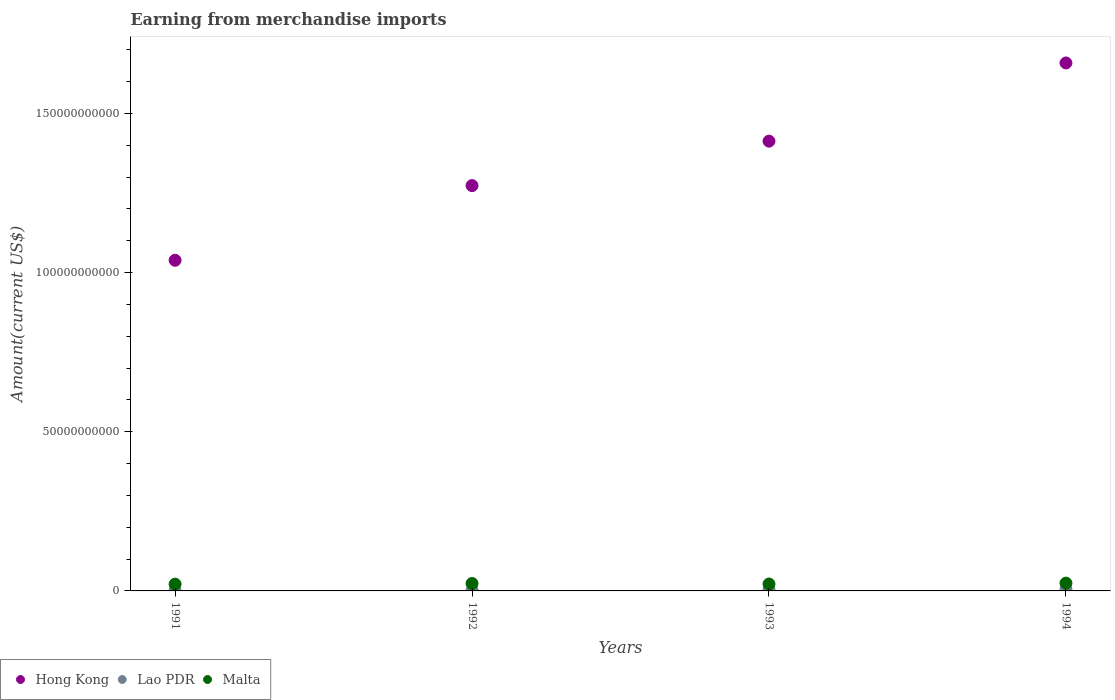Is the number of dotlines equal to the number of legend labels?
Offer a terse response. Yes. What is the amount earned from merchandise imports in Malta in 1992?
Give a very brief answer. 2.33e+09. Across all years, what is the maximum amount earned from merchandise imports in Hong Kong?
Give a very brief answer. 1.66e+11. Across all years, what is the minimum amount earned from merchandise imports in Hong Kong?
Offer a very short reply. 1.04e+11. In which year was the amount earned from merchandise imports in Lao PDR maximum?
Your response must be concise. 1994. In which year was the amount earned from merchandise imports in Hong Kong minimum?
Offer a very short reply. 1991. What is the total amount earned from merchandise imports in Lao PDR in the graph?
Your answer should be compact. 1.44e+09. What is the difference between the amount earned from merchandise imports in Hong Kong in 1993 and that in 1994?
Offer a terse response. -2.46e+1. What is the difference between the amount earned from merchandise imports in Hong Kong in 1991 and the amount earned from merchandise imports in Malta in 1994?
Give a very brief answer. 1.01e+11. What is the average amount earned from merchandise imports in Malta per year?
Offer a very short reply. 2.27e+09. In the year 1993, what is the difference between the amount earned from merchandise imports in Malta and amount earned from merchandise imports in Hong Kong?
Offer a terse response. -1.39e+11. In how many years, is the amount earned from merchandise imports in Lao PDR greater than 140000000000 US$?
Give a very brief answer. 0. What is the ratio of the amount earned from merchandise imports in Malta in 1992 to that in 1993?
Provide a short and direct response. 1.07. Is the difference between the amount earned from merchandise imports in Malta in 1993 and 1994 greater than the difference between the amount earned from merchandise imports in Hong Kong in 1993 and 1994?
Offer a very short reply. Yes. What is the difference between the highest and the second highest amount earned from merchandise imports in Hong Kong?
Provide a short and direct response. 2.46e+1. What is the difference between the highest and the lowest amount earned from merchandise imports in Hong Kong?
Your answer should be compact. 6.20e+1. In how many years, is the amount earned from merchandise imports in Malta greater than the average amount earned from merchandise imports in Malta taken over all years?
Offer a terse response. 2. Is the amount earned from merchandise imports in Hong Kong strictly greater than the amount earned from merchandise imports in Malta over the years?
Provide a short and direct response. Yes. Is the amount earned from merchandise imports in Lao PDR strictly less than the amount earned from merchandise imports in Hong Kong over the years?
Provide a succinct answer. Yes. How many years are there in the graph?
Offer a terse response. 4. What is the difference between two consecutive major ticks on the Y-axis?
Provide a succinct answer. 5.00e+1. Does the graph contain any zero values?
Offer a very short reply. No. Does the graph contain grids?
Provide a succinct answer. No. Where does the legend appear in the graph?
Your answer should be compact. Bottom left. What is the title of the graph?
Provide a succinct answer. Earning from merchandise imports. What is the label or title of the X-axis?
Give a very brief answer. Years. What is the label or title of the Y-axis?
Offer a very short reply. Amount(current US$). What is the Amount(current US$) of Hong Kong in 1991?
Your answer should be very brief. 1.04e+11. What is the Amount(current US$) in Lao PDR in 1991?
Give a very brief answer. 1.70e+08. What is the Amount(current US$) of Malta in 1991?
Your response must be concise. 2.13e+09. What is the Amount(current US$) in Hong Kong in 1992?
Your response must be concise. 1.27e+11. What is the Amount(current US$) of Lao PDR in 1992?
Give a very brief answer. 2.70e+08. What is the Amount(current US$) of Malta in 1992?
Give a very brief answer. 2.33e+09. What is the Amount(current US$) of Hong Kong in 1993?
Your answer should be compact. 1.41e+11. What is the Amount(current US$) in Lao PDR in 1993?
Ensure brevity in your answer.  4.32e+08. What is the Amount(current US$) of Malta in 1993?
Ensure brevity in your answer.  2.17e+09. What is the Amount(current US$) of Hong Kong in 1994?
Your response must be concise. 1.66e+11. What is the Amount(current US$) in Lao PDR in 1994?
Make the answer very short. 5.64e+08. What is the Amount(current US$) of Malta in 1994?
Your answer should be compact. 2.45e+09. Across all years, what is the maximum Amount(current US$) in Hong Kong?
Keep it short and to the point. 1.66e+11. Across all years, what is the maximum Amount(current US$) of Lao PDR?
Keep it short and to the point. 5.64e+08. Across all years, what is the maximum Amount(current US$) in Malta?
Provide a short and direct response. 2.45e+09. Across all years, what is the minimum Amount(current US$) of Hong Kong?
Offer a terse response. 1.04e+11. Across all years, what is the minimum Amount(current US$) of Lao PDR?
Provide a succinct answer. 1.70e+08. Across all years, what is the minimum Amount(current US$) of Malta?
Your answer should be compact. 2.13e+09. What is the total Amount(current US$) in Hong Kong in the graph?
Provide a succinct answer. 5.38e+11. What is the total Amount(current US$) of Lao PDR in the graph?
Ensure brevity in your answer.  1.44e+09. What is the total Amount(current US$) of Malta in the graph?
Your answer should be compact. 9.08e+09. What is the difference between the Amount(current US$) of Hong Kong in 1991 and that in 1992?
Your answer should be compact. -2.35e+1. What is the difference between the Amount(current US$) of Lao PDR in 1991 and that in 1992?
Offer a very short reply. -1.00e+08. What is the difference between the Amount(current US$) in Malta in 1991 and that in 1992?
Your answer should be very brief. -2.01e+08. What is the difference between the Amount(current US$) of Hong Kong in 1991 and that in 1993?
Make the answer very short. -3.74e+1. What is the difference between the Amount(current US$) of Lao PDR in 1991 and that in 1993?
Keep it short and to the point. -2.62e+08. What is the difference between the Amount(current US$) of Malta in 1991 and that in 1993?
Offer a very short reply. -4.40e+07. What is the difference between the Amount(current US$) in Hong Kong in 1991 and that in 1994?
Provide a short and direct response. -6.20e+1. What is the difference between the Amount(current US$) of Lao PDR in 1991 and that in 1994?
Offer a terse response. -3.94e+08. What is the difference between the Amount(current US$) of Malta in 1991 and that in 1994?
Give a very brief answer. -3.17e+08. What is the difference between the Amount(current US$) of Hong Kong in 1992 and that in 1993?
Your answer should be very brief. -1.40e+1. What is the difference between the Amount(current US$) of Lao PDR in 1992 and that in 1993?
Your answer should be compact. -1.62e+08. What is the difference between the Amount(current US$) of Malta in 1992 and that in 1993?
Your answer should be compact. 1.57e+08. What is the difference between the Amount(current US$) of Hong Kong in 1992 and that in 1994?
Your response must be concise. -3.85e+1. What is the difference between the Amount(current US$) in Lao PDR in 1992 and that in 1994?
Offer a terse response. -2.94e+08. What is the difference between the Amount(current US$) in Malta in 1992 and that in 1994?
Give a very brief answer. -1.16e+08. What is the difference between the Amount(current US$) of Hong Kong in 1993 and that in 1994?
Provide a short and direct response. -2.46e+1. What is the difference between the Amount(current US$) of Lao PDR in 1993 and that in 1994?
Offer a terse response. -1.32e+08. What is the difference between the Amount(current US$) of Malta in 1993 and that in 1994?
Ensure brevity in your answer.  -2.73e+08. What is the difference between the Amount(current US$) in Hong Kong in 1991 and the Amount(current US$) in Lao PDR in 1992?
Make the answer very short. 1.04e+11. What is the difference between the Amount(current US$) of Hong Kong in 1991 and the Amount(current US$) of Malta in 1992?
Ensure brevity in your answer.  1.02e+11. What is the difference between the Amount(current US$) of Lao PDR in 1991 and the Amount(current US$) of Malta in 1992?
Ensure brevity in your answer.  -2.16e+09. What is the difference between the Amount(current US$) of Hong Kong in 1991 and the Amount(current US$) of Lao PDR in 1993?
Give a very brief answer. 1.03e+11. What is the difference between the Amount(current US$) of Hong Kong in 1991 and the Amount(current US$) of Malta in 1993?
Provide a short and direct response. 1.02e+11. What is the difference between the Amount(current US$) in Lao PDR in 1991 and the Amount(current US$) in Malta in 1993?
Keep it short and to the point. -2.00e+09. What is the difference between the Amount(current US$) in Hong Kong in 1991 and the Amount(current US$) in Lao PDR in 1994?
Provide a succinct answer. 1.03e+11. What is the difference between the Amount(current US$) of Hong Kong in 1991 and the Amount(current US$) of Malta in 1994?
Provide a succinct answer. 1.01e+11. What is the difference between the Amount(current US$) in Lao PDR in 1991 and the Amount(current US$) in Malta in 1994?
Offer a terse response. -2.28e+09. What is the difference between the Amount(current US$) of Hong Kong in 1992 and the Amount(current US$) of Lao PDR in 1993?
Your answer should be compact. 1.27e+11. What is the difference between the Amount(current US$) of Hong Kong in 1992 and the Amount(current US$) of Malta in 1993?
Offer a terse response. 1.25e+11. What is the difference between the Amount(current US$) of Lao PDR in 1992 and the Amount(current US$) of Malta in 1993?
Offer a terse response. -1.90e+09. What is the difference between the Amount(current US$) in Hong Kong in 1992 and the Amount(current US$) in Lao PDR in 1994?
Your answer should be compact. 1.27e+11. What is the difference between the Amount(current US$) in Hong Kong in 1992 and the Amount(current US$) in Malta in 1994?
Provide a succinct answer. 1.25e+11. What is the difference between the Amount(current US$) of Lao PDR in 1992 and the Amount(current US$) of Malta in 1994?
Offer a very short reply. -2.18e+09. What is the difference between the Amount(current US$) in Hong Kong in 1993 and the Amount(current US$) in Lao PDR in 1994?
Your answer should be very brief. 1.41e+11. What is the difference between the Amount(current US$) in Hong Kong in 1993 and the Amount(current US$) in Malta in 1994?
Provide a short and direct response. 1.39e+11. What is the difference between the Amount(current US$) in Lao PDR in 1993 and the Amount(current US$) in Malta in 1994?
Offer a terse response. -2.02e+09. What is the average Amount(current US$) of Hong Kong per year?
Keep it short and to the point. 1.35e+11. What is the average Amount(current US$) of Lao PDR per year?
Make the answer very short. 3.59e+08. What is the average Amount(current US$) in Malta per year?
Your response must be concise. 2.27e+09. In the year 1991, what is the difference between the Amount(current US$) of Hong Kong and Amount(current US$) of Lao PDR?
Ensure brevity in your answer.  1.04e+11. In the year 1991, what is the difference between the Amount(current US$) in Hong Kong and Amount(current US$) in Malta?
Your answer should be compact. 1.02e+11. In the year 1991, what is the difference between the Amount(current US$) of Lao PDR and Amount(current US$) of Malta?
Your response must be concise. -1.96e+09. In the year 1992, what is the difference between the Amount(current US$) in Hong Kong and Amount(current US$) in Lao PDR?
Offer a very short reply. 1.27e+11. In the year 1992, what is the difference between the Amount(current US$) in Hong Kong and Amount(current US$) in Malta?
Your response must be concise. 1.25e+11. In the year 1992, what is the difference between the Amount(current US$) in Lao PDR and Amount(current US$) in Malta?
Offer a very short reply. -2.06e+09. In the year 1993, what is the difference between the Amount(current US$) of Hong Kong and Amount(current US$) of Lao PDR?
Give a very brief answer. 1.41e+11. In the year 1993, what is the difference between the Amount(current US$) of Hong Kong and Amount(current US$) of Malta?
Offer a terse response. 1.39e+11. In the year 1993, what is the difference between the Amount(current US$) in Lao PDR and Amount(current US$) in Malta?
Offer a very short reply. -1.74e+09. In the year 1994, what is the difference between the Amount(current US$) in Hong Kong and Amount(current US$) in Lao PDR?
Provide a succinct answer. 1.65e+11. In the year 1994, what is the difference between the Amount(current US$) in Hong Kong and Amount(current US$) in Malta?
Offer a terse response. 1.63e+11. In the year 1994, what is the difference between the Amount(current US$) in Lao PDR and Amount(current US$) in Malta?
Ensure brevity in your answer.  -1.88e+09. What is the ratio of the Amount(current US$) of Hong Kong in 1991 to that in 1992?
Offer a very short reply. 0.82. What is the ratio of the Amount(current US$) in Lao PDR in 1991 to that in 1992?
Give a very brief answer. 0.63. What is the ratio of the Amount(current US$) of Malta in 1991 to that in 1992?
Provide a succinct answer. 0.91. What is the ratio of the Amount(current US$) of Hong Kong in 1991 to that in 1993?
Your answer should be very brief. 0.74. What is the ratio of the Amount(current US$) of Lao PDR in 1991 to that in 1993?
Offer a terse response. 0.39. What is the ratio of the Amount(current US$) of Malta in 1991 to that in 1993?
Provide a short and direct response. 0.98. What is the ratio of the Amount(current US$) in Hong Kong in 1991 to that in 1994?
Your response must be concise. 0.63. What is the ratio of the Amount(current US$) in Lao PDR in 1991 to that in 1994?
Offer a very short reply. 0.3. What is the ratio of the Amount(current US$) of Malta in 1991 to that in 1994?
Give a very brief answer. 0.87. What is the ratio of the Amount(current US$) of Hong Kong in 1992 to that in 1993?
Your answer should be very brief. 0.9. What is the ratio of the Amount(current US$) of Lao PDR in 1992 to that in 1993?
Make the answer very short. 0.62. What is the ratio of the Amount(current US$) in Malta in 1992 to that in 1993?
Provide a succinct answer. 1.07. What is the ratio of the Amount(current US$) in Hong Kong in 1992 to that in 1994?
Your answer should be very brief. 0.77. What is the ratio of the Amount(current US$) of Lao PDR in 1992 to that in 1994?
Your response must be concise. 0.48. What is the ratio of the Amount(current US$) of Malta in 1992 to that in 1994?
Provide a short and direct response. 0.95. What is the ratio of the Amount(current US$) in Hong Kong in 1993 to that in 1994?
Your answer should be very brief. 0.85. What is the ratio of the Amount(current US$) in Lao PDR in 1993 to that in 1994?
Your response must be concise. 0.77. What is the ratio of the Amount(current US$) in Malta in 1993 to that in 1994?
Ensure brevity in your answer.  0.89. What is the difference between the highest and the second highest Amount(current US$) of Hong Kong?
Your answer should be very brief. 2.46e+1. What is the difference between the highest and the second highest Amount(current US$) of Lao PDR?
Make the answer very short. 1.32e+08. What is the difference between the highest and the second highest Amount(current US$) in Malta?
Provide a succinct answer. 1.16e+08. What is the difference between the highest and the lowest Amount(current US$) in Hong Kong?
Give a very brief answer. 6.20e+1. What is the difference between the highest and the lowest Amount(current US$) in Lao PDR?
Ensure brevity in your answer.  3.94e+08. What is the difference between the highest and the lowest Amount(current US$) of Malta?
Your response must be concise. 3.17e+08. 